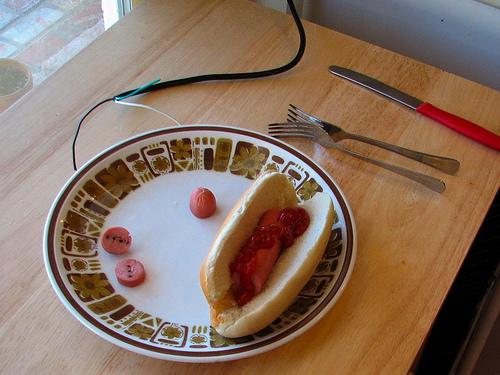Can you see the people who took the picture?
Be succinct. No. Where are the forks?
Keep it brief. Table. How many forks are on the table?
Answer briefly. 2. What toppings are on the dish?
Keep it brief. Ketchup. What pattern is on the plate?
Concise answer only. Floral. 